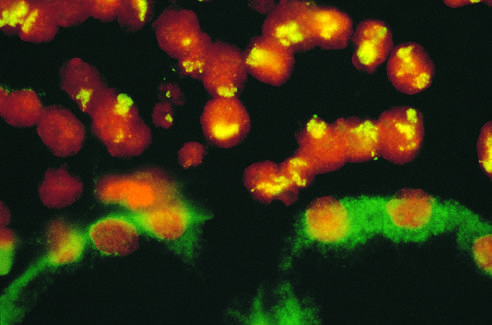does section of an involved lacrimal gland correspond to amplified n-myc in the form of homogeneously staining regions?
Answer the question using a single word or phrase. No 